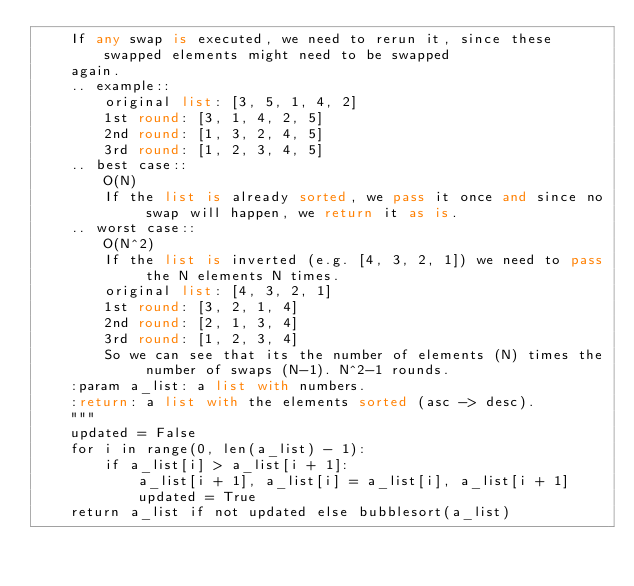Convert code to text. <code><loc_0><loc_0><loc_500><loc_500><_Python_>    If any swap is executed, we need to rerun it, since these swapped elements might need to be swapped
    again.
    .. example::
        original list: [3, 5, 1, 4, 2]
        1st round: [3, 1, 4, 2, 5]
        2nd round: [1, 3, 2, 4, 5]
        3rd round: [1, 2, 3, 4, 5]
    .. best case::
        O(N)
        If the list is already sorted, we pass it once and since no swap will happen, we return it as is.
    .. worst case::
        O(N^2)
        If the list is inverted (e.g. [4, 3, 2, 1]) we need to pass the N elements N times.
        original list: [4, 3, 2, 1]
        1st round: [3, 2, 1, 4]
        2nd round: [2, 1, 3, 4]
        3rd round: [1, 2, 3, 4]
        So we can see that its the number of elements (N) times the number of swaps (N-1). N^2-1 rounds.
    :param a_list: a list with numbers.
    :return: a list with the elements sorted (asc -> desc).
    """
    updated = False
    for i in range(0, len(a_list) - 1):
        if a_list[i] > a_list[i + 1]:
            a_list[i + 1], a_list[i] = a_list[i], a_list[i + 1]
            updated = True
    return a_list if not updated else bubblesort(a_list)
</code> 